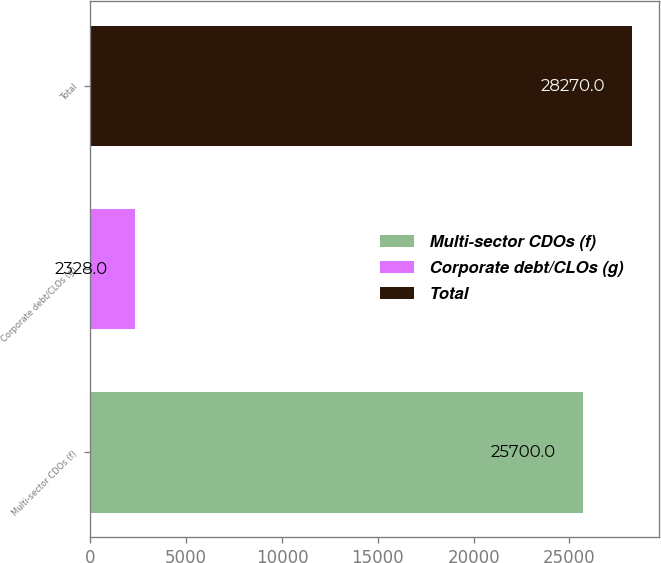<chart> <loc_0><loc_0><loc_500><loc_500><bar_chart><fcel>Multi-sector CDOs (f)<fcel>Corporate debt/CLOs (g)<fcel>Total<nl><fcel>25700<fcel>2328<fcel>28270<nl></chart> 